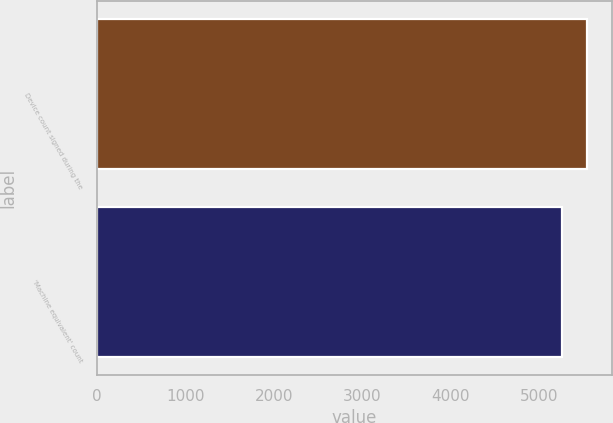<chart> <loc_0><loc_0><loc_500><loc_500><bar_chart><fcel>Device count signed during the<fcel>'Machine equivalent' count<nl><fcel>5537<fcel>5250<nl></chart> 